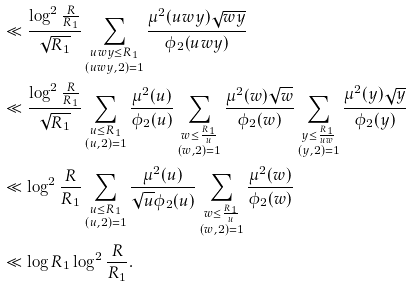Convert formula to latex. <formula><loc_0><loc_0><loc_500><loc_500>& \ll \frac { \log ^ { 2 } \frac { R } { R _ { 1 } } } { \sqrt { R _ { 1 } } } \sum _ { \substack { u w y \leq R _ { 1 } \\ ( u w y , 2 ) = 1 } } \frac { \mu ^ { 2 } ( u w y ) \sqrt { w y } } { \phi _ { 2 } ( u w y ) } \\ & \ll \frac { \log ^ { 2 } \frac { R } { R _ { 1 } } } { \sqrt { R _ { 1 } } } \sum _ { \substack { u \leq R _ { 1 } \\ ( u , 2 ) = 1 } } \frac { \mu ^ { 2 } ( u ) } { \phi _ { 2 } ( u ) } \sum _ { \substack { w \leq \frac { R _ { 1 } } { u } \\ ( w , 2 ) = 1 } } \frac { \mu ^ { 2 } ( w ) \sqrt { w } } { \phi _ { 2 } ( w ) } \sum _ { \substack { y \leq \frac { R _ { 1 } } { u w } \\ ( y , 2 ) = 1 } } \frac { \mu ^ { 2 } ( y ) \sqrt { y } } { \phi _ { 2 } ( y ) } \\ & \ll \log ^ { 2 } \frac { R } { R _ { 1 } } \sum _ { \substack { u \leq R _ { 1 } \\ ( u , 2 ) = 1 } } \frac { \mu ^ { 2 } ( u ) } { \sqrt { u } \phi _ { 2 } ( u ) } \sum _ { \substack { w \leq \frac { R _ { 1 } } { u } \\ ( w , 2 ) = 1 } } \frac { \mu ^ { 2 } ( w ) } { \phi _ { 2 } ( w ) } \\ & \ll \log R _ { 1 } \log ^ { 2 } \frac { R } { R _ { 1 } } .</formula> 